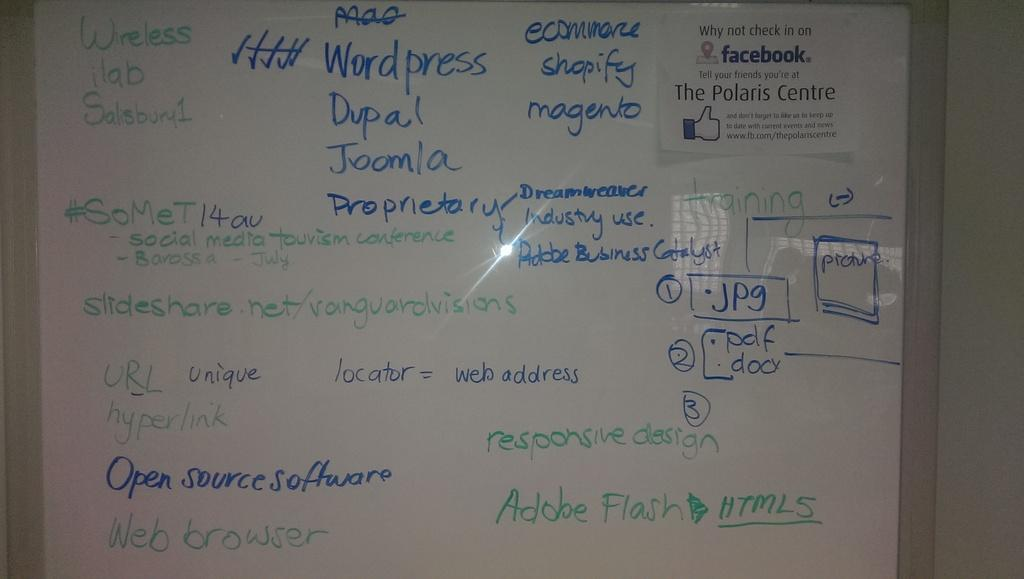<image>
Present a compact description of the photo's key features. the word open that is on a white board 